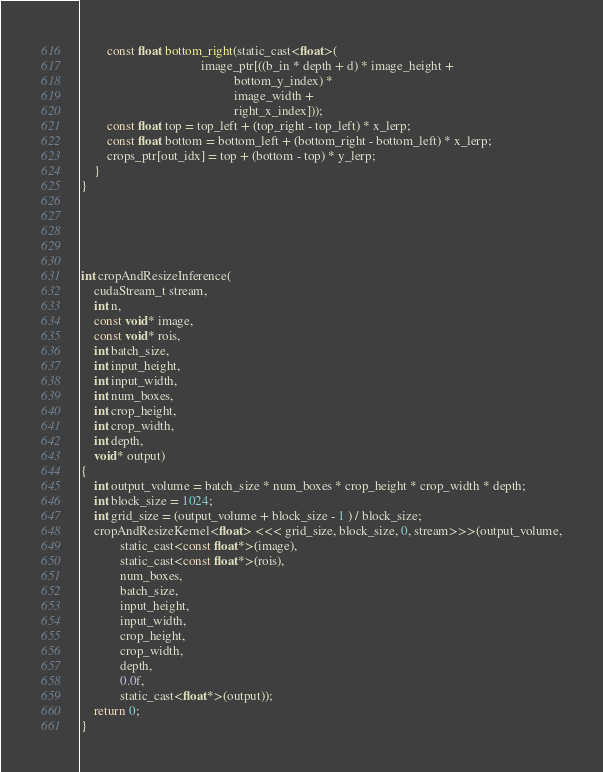Convert code to text. <code><loc_0><loc_0><loc_500><loc_500><_Cuda_>        const float bottom_right(static_cast<float>(
                                     image_ptr[((b_in * depth + d) * image_height +
                                               bottom_y_index) *
                                               image_width +
                                               right_x_index]));
        const float top = top_left + (top_right - top_left) * x_lerp;
        const float bottom = bottom_left + (bottom_right - bottom_left) * x_lerp;
        crops_ptr[out_idx] = top + (bottom - top) * y_lerp;
    }
}





int cropAndResizeInference(
    cudaStream_t stream,
    int n,
    const void* image,
    const void* rois,
    int batch_size,
    int input_height,
    int input_width,
    int num_boxes,
    int crop_height,
    int crop_width,
    int depth,
    void* output)
{
    int output_volume = batch_size * num_boxes * crop_height * crop_width * depth;
    int block_size = 1024;
    int grid_size = (output_volume + block_size - 1 ) / block_size;
    cropAndResizeKernel<float> <<< grid_size, block_size, 0, stream>>>(output_volume,
            static_cast<const float*>(image),
            static_cast<const float*>(rois),
            num_boxes,
            batch_size,
            input_height,
            input_width,
            crop_height,
            crop_width,
            depth,
            0.0f,
            static_cast<float*>(output));
    return 0;
}
</code> 